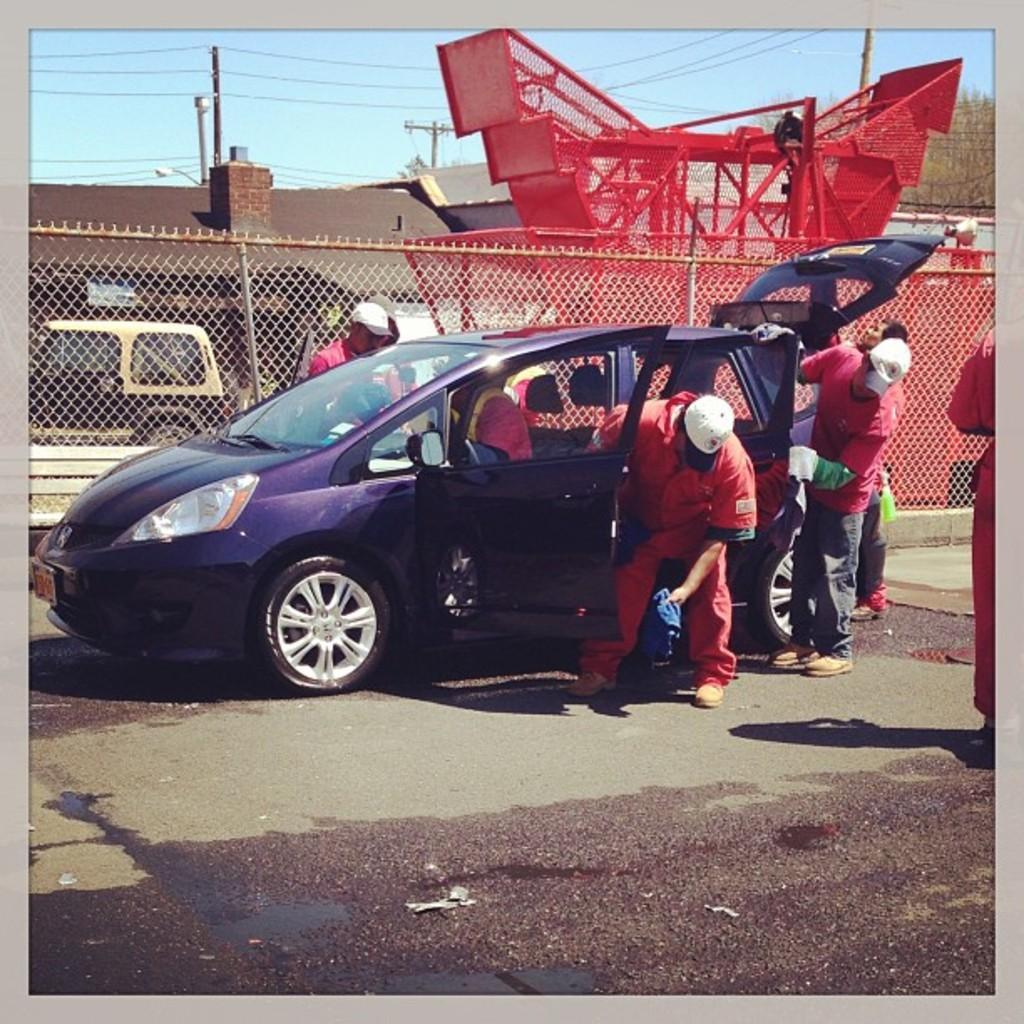Could you give a brief overview of what you see in this image? In the center we can see one car. Around car we can see few persons were standing. In the background there is a sky,fence,tree,roof,building and vehicle. 